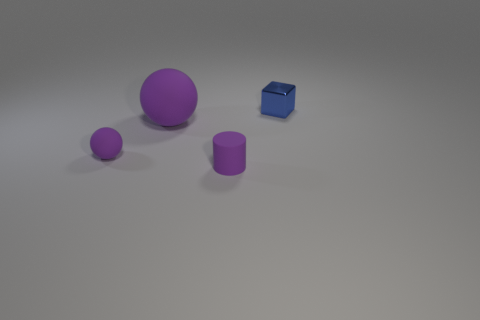Are there fewer small metallic blocks that are left of the purple cylinder than small metallic things that are in front of the tiny block?
Your response must be concise. No. Is the number of purple spheres greater than the number of gray balls?
Keep it short and to the point. Yes. What is the large thing made of?
Your answer should be very brief. Rubber. The small matte object in front of the small purple rubber sphere is what color?
Your response must be concise. Purple. Are there more large rubber things to the left of the cylinder than tiny cylinders that are to the right of the small purple matte sphere?
Ensure brevity in your answer.  No. How big is the purple object in front of the small thing that is to the left of the purple object to the right of the large purple sphere?
Your response must be concise. Small. Are there any tiny shiny things of the same color as the tiny metallic block?
Your answer should be very brief. No. What number of cylinders are there?
Provide a succinct answer. 1. What material is the ball right of the tiny purple rubber thing behind the matte object that is right of the large purple matte ball?
Offer a terse response. Rubber. Are there any other spheres that have the same material as the large purple ball?
Make the answer very short. Yes. 